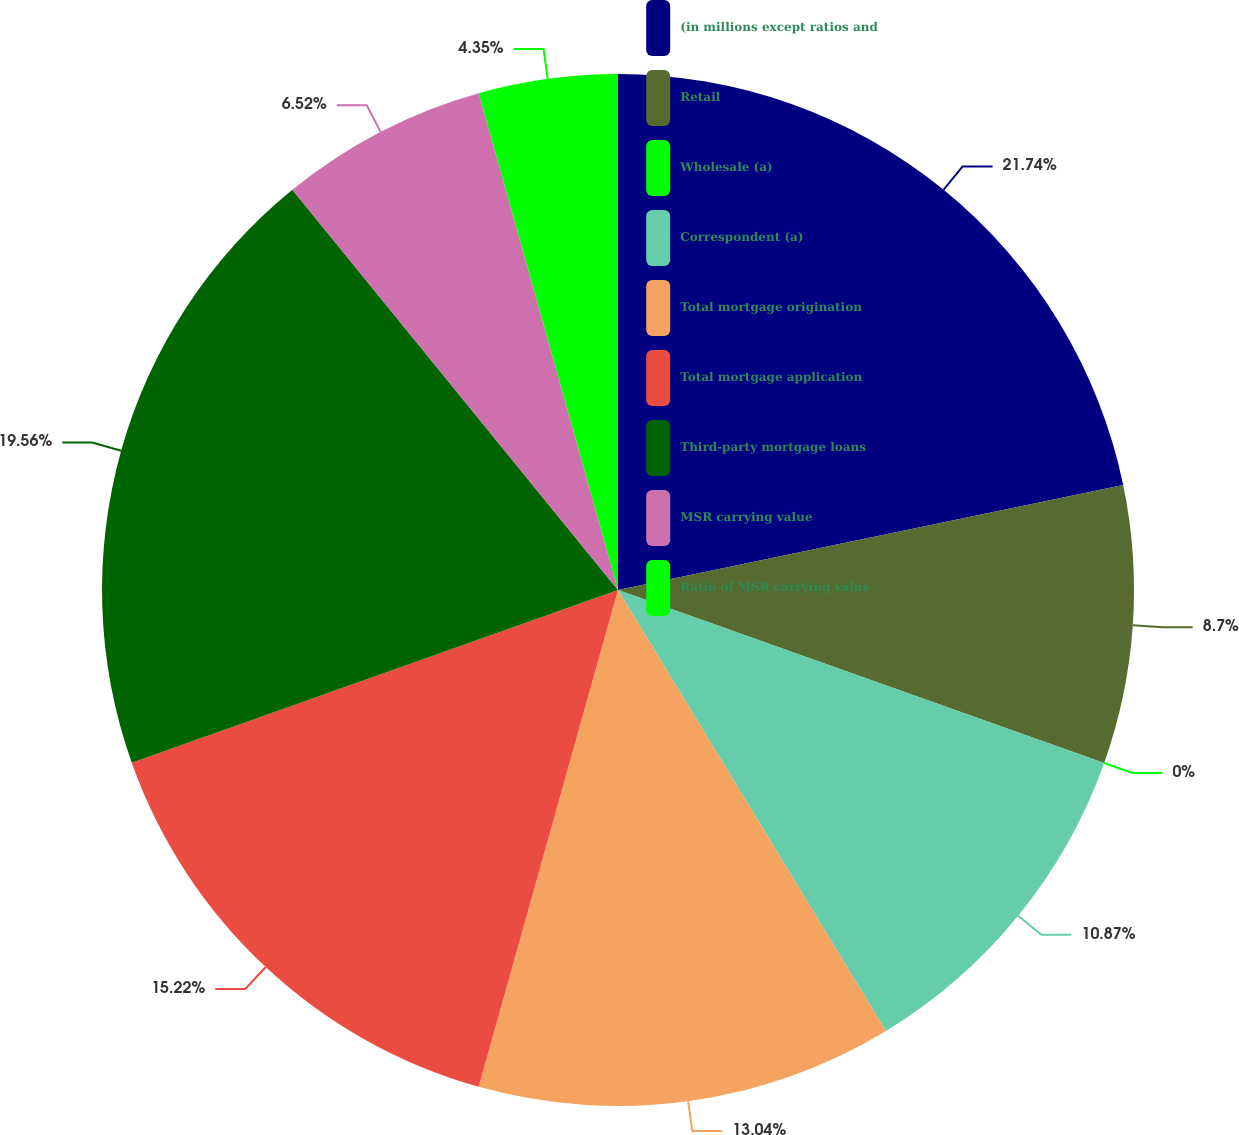<chart> <loc_0><loc_0><loc_500><loc_500><pie_chart><fcel>(in millions except ratios and<fcel>Retail<fcel>Wholesale (a)<fcel>Correspondent (a)<fcel>Total mortgage origination<fcel>Total mortgage application<fcel>Third-party mortgage loans<fcel>MSR carrying value<fcel>Ratio of MSR carrying value<nl><fcel>21.74%<fcel>8.7%<fcel>0.0%<fcel>10.87%<fcel>13.04%<fcel>15.22%<fcel>19.56%<fcel>6.52%<fcel>4.35%<nl></chart> 